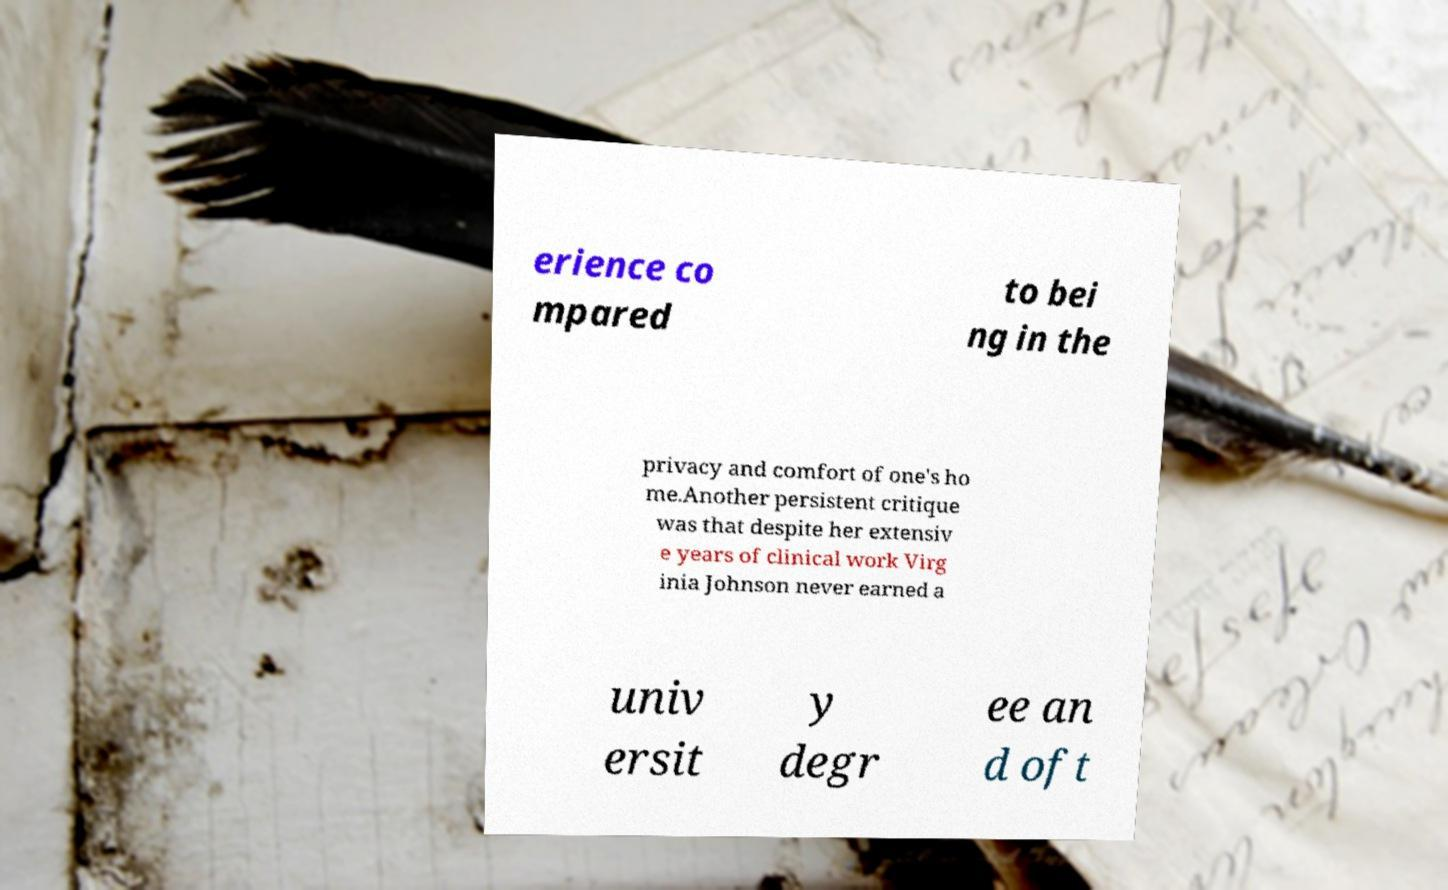Please identify and transcribe the text found in this image. erience co mpared to bei ng in the privacy and comfort of one's ho me.Another persistent critique was that despite her extensiv e years of clinical work Virg inia Johnson never earned a univ ersit y degr ee an d oft 